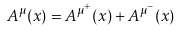Convert formula to latex. <formula><loc_0><loc_0><loc_500><loc_500>A ^ { \mu } ( x ) = A ^ { \mu ^ { + } } ( x ) + A ^ { \mu ^ { - } } ( x )</formula> 